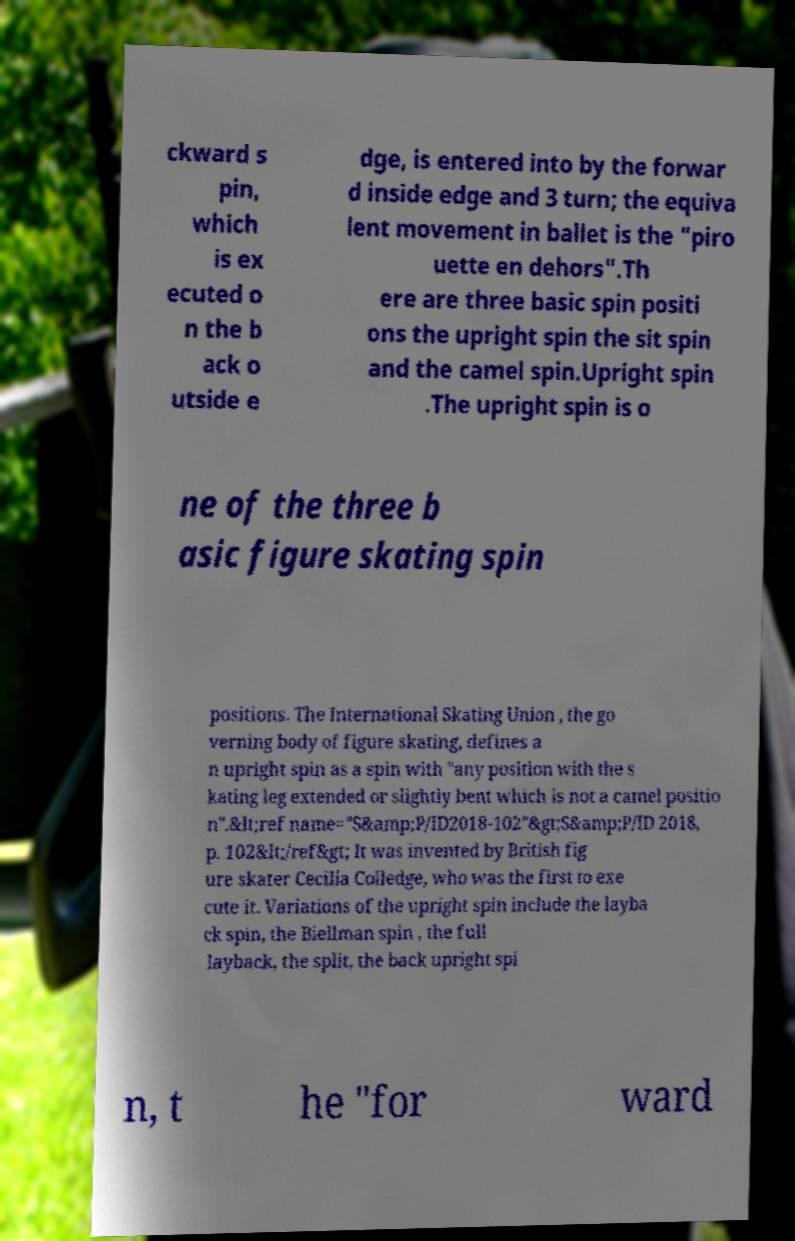For documentation purposes, I need the text within this image transcribed. Could you provide that? ckward s pin, which is ex ecuted o n the b ack o utside e dge, is entered into by the forwar d inside edge and 3 turn; the equiva lent movement in ballet is the "piro uette en dehors".Th ere are three basic spin positi ons the upright spin the sit spin and the camel spin.Upright spin .The upright spin is o ne of the three b asic figure skating spin positions. The International Skating Union , the go verning body of figure skating, defines a n upright spin as a spin with "any position with the s kating leg extended or slightly bent which is not a camel positio n".&lt;ref name="S&amp;P/ID2018-102"&gt;S&amp;P/ID 2018, p. 102&lt;/ref&gt; It was invented by British fig ure skater Cecilia Colledge, who was the first to exe cute it. Variations of the upright spin include the layba ck spin, the Biellman spin , the full layback, the split, the back upright spi n, t he "for ward 